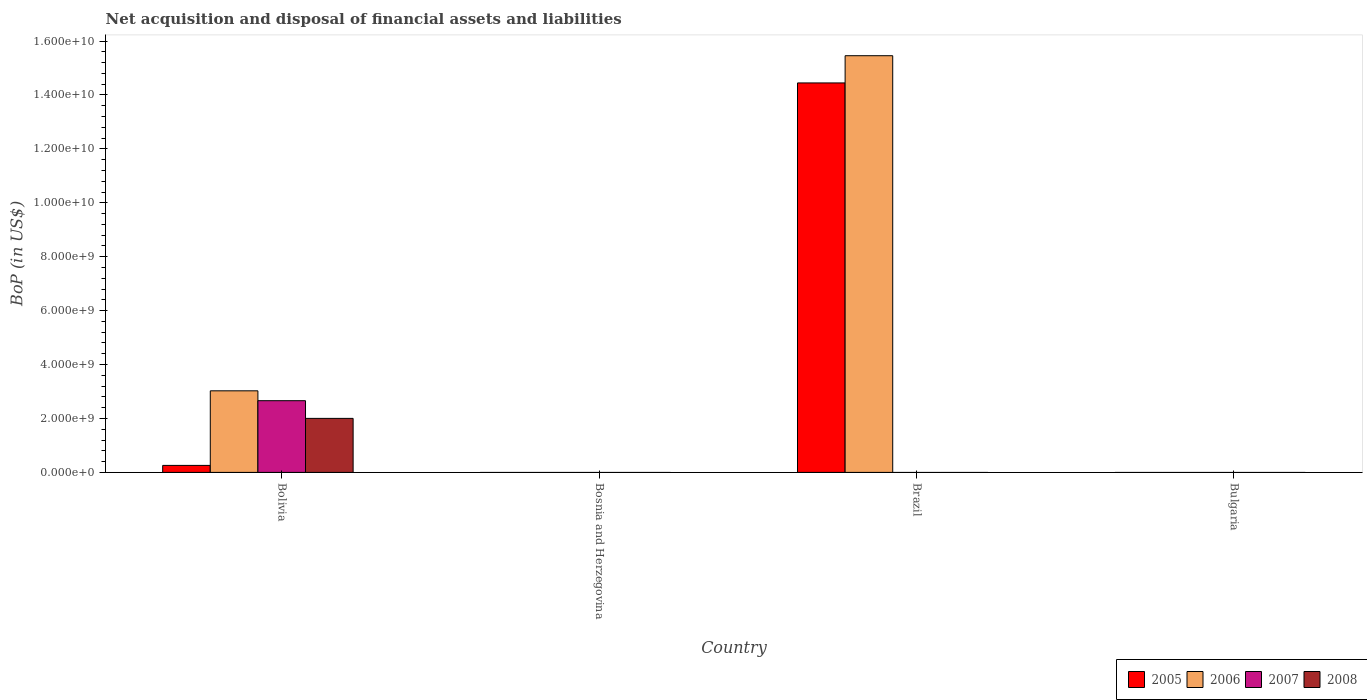How many different coloured bars are there?
Keep it short and to the point. 4. Are the number of bars on each tick of the X-axis equal?
Make the answer very short. No. In how many cases, is the number of bars for a given country not equal to the number of legend labels?
Your response must be concise. 3. What is the Balance of Payments in 2006 in Bosnia and Herzegovina?
Ensure brevity in your answer.  0. Across all countries, what is the maximum Balance of Payments in 2006?
Make the answer very short. 1.55e+1. What is the total Balance of Payments in 2005 in the graph?
Your response must be concise. 1.47e+1. What is the difference between the Balance of Payments in 2006 in Bosnia and Herzegovina and the Balance of Payments in 2008 in Bolivia?
Make the answer very short. -2.00e+09. What is the average Balance of Payments in 2006 per country?
Make the answer very short. 4.62e+09. What is the difference between the Balance of Payments of/in 2007 and Balance of Payments of/in 2006 in Bolivia?
Give a very brief answer. -3.66e+08. In how many countries, is the Balance of Payments in 2007 greater than 5200000000 US$?
Offer a terse response. 0. What is the difference between the highest and the lowest Balance of Payments in 2008?
Ensure brevity in your answer.  2.00e+09. In how many countries, is the Balance of Payments in 2006 greater than the average Balance of Payments in 2006 taken over all countries?
Provide a succinct answer. 1. Is it the case that in every country, the sum of the Balance of Payments in 2005 and Balance of Payments in 2008 is greater than the sum of Balance of Payments in 2006 and Balance of Payments in 2007?
Keep it short and to the point. No. How many countries are there in the graph?
Offer a very short reply. 4. Are the values on the major ticks of Y-axis written in scientific E-notation?
Offer a terse response. Yes. Does the graph contain grids?
Ensure brevity in your answer.  No. How many legend labels are there?
Your response must be concise. 4. How are the legend labels stacked?
Ensure brevity in your answer.  Horizontal. What is the title of the graph?
Your response must be concise. Net acquisition and disposal of financial assets and liabilities. What is the label or title of the Y-axis?
Provide a short and direct response. BoP (in US$). What is the BoP (in US$) of 2005 in Bolivia?
Ensure brevity in your answer.  2.59e+08. What is the BoP (in US$) of 2006 in Bolivia?
Offer a very short reply. 3.03e+09. What is the BoP (in US$) in 2007 in Bolivia?
Keep it short and to the point. 2.66e+09. What is the BoP (in US$) in 2008 in Bolivia?
Your answer should be very brief. 2.00e+09. What is the BoP (in US$) of 2005 in Bosnia and Herzegovina?
Offer a very short reply. 0. What is the BoP (in US$) in 2005 in Brazil?
Provide a short and direct response. 1.44e+1. What is the BoP (in US$) in 2006 in Brazil?
Your response must be concise. 1.55e+1. What is the BoP (in US$) of 2005 in Bulgaria?
Your response must be concise. 0. What is the BoP (in US$) of 2006 in Bulgaria?
Make the answer very short. 0. What is the BoP (in US$) of 2008 in Bulgaria?
Make the answer very short. 0. Across all countries, what is the maximum BoP (in US$) in 2005?
Offer a terse response. 1.44e+1. Across all countries, what is the maximum BoP (in US$) of 2006?
Keep it short and to the point. 1.55e+1. Across all countries, what is the maximum BoP (in US$) in 2007?
Keep it short and to the point. 2.66e+09. Across all countries, what is the maximum BoP (in US$) in 2008?
Your answer should be very brief. 2.00e+09. Across all countries, what is the minimum BoP (in US$) in 2005?
Your answer should be compact. 0. Across all countries, what is the minimum BoP (in US$) in 2008?
Give a very brief answer. 0. What is the total BoP (in US$) in 2005 in the graph?
Your answer should be compact. 1.47e+1. What is the total BoP (in US$) in 2006 in the graph?
Ensure brevity in your answer.  1.85e+1. What is the total BoP (in US$) in 2007 in the graph?
Your response must be concise. 2.66e+09. What is the total BoP (in US$) of 2008 in the graph?
Provide a succinct answer. 2.00e+09. What is the difference between the BoP (in US$) of 2005 in Bolivia and that in Brazil?
Offer a terse response. -1.42e+1. What is the difference between the BoP (in US$) of 2006 in Bolivia and that in Brazil?
Your answer should be compact. -1.24e+1. What is the difference between the BoP (in US$) of 2005 in Bolivia and the BoP (in US$) of 2006 in Brazil?
Give a very brief answer. -1.52e+1. What is the average BoP (in US$) of 2005 per country?
Make the answer very short. 3.68e+09. What is the average BoP (in US$) of 2006 per country?
Offer a very short reply. 4.62e+09. What is the average BoP (in US$) in 2007 per country?
Offer a very short reply. 6.65e+08. What is the average BoP (in US$) of 2008 per country?
Offer a terse response. 5.01e+08. What is the difference between the BoP (in US$) of 2005 and BoP (in US$) of 2006 in Bolivia?
Your answer should be very brief. -2.77e+09. What is the difference between the BoP (in US$) of 2005 and BoP (in US$) of 2007 in Bolivia?
Ensure brevity in your answer.  -2.40e+09. What is the difference between the BoP (in US$) of 2005 and BoP (in US$) of 2008 in Bolivia?
Offer a very short reply. -1.74e+09. What is the difference between the BoP (in US$) in 2006 and BoP (in US$) in 2007 in Bolivia?
Give a very brief answer. 3.66e+08. What is the difference between the BoP (in US$) of 2006 and BoP (in US$) of 2008 in Bolivia?
Your answer should be compact. 1.02e+09. What is the difference between the BoP (in US$) of 2007 and BoP (in US$) of 2008 in Bolivia?
Keep it short and to the point. 6.56e+08. What is the difference between the BoP (in US$) in 2005 and BoP (in US$) in 2006 in Brazil?
Provide a succinct answer. -1.01e+09. What is the ratio of the BoP (in US$) in 2005 in Bolivia to that in Brazil?
Provide a succinct answer. 0.02. What is the ratio of the BoP (in US$) in 2006 in Bolivia to that in Brazil?
Your response must be concise. 0.2. What is the difference between the highest and the lowest BoP (in US$) of 2005?
Make the answer very short. 1.44e+1. What is the difference between the highest and the lowest BoP (in US$) in 2006?
Keep it short and to the point. 1.55e+1. What is the difference between the highest and the lowest BoP (in US$) in 2007?
Ensure brevity in your answer.  2.66e+09. What is the difference between the highest and the lowest BoP (in US$) in 2008?
Make the answer very short. 2.00e+09. 